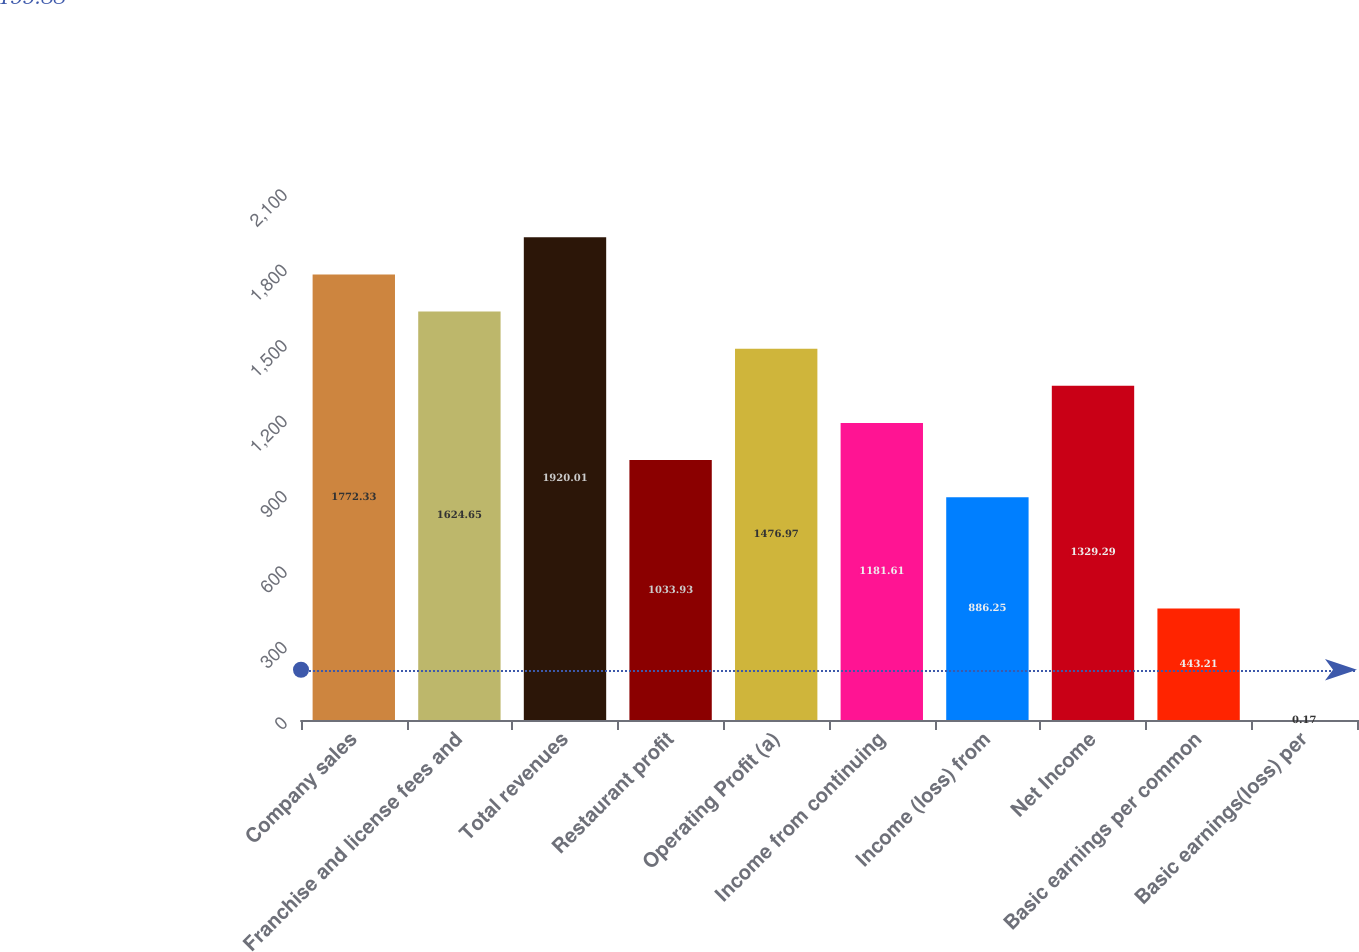<chart> <loc_0><loc_0><loc_500><loc_500><bar_chart><fcel>Company sales<fcel>Franchise and license fees and<fcel>Total revenues<fcel>Restaurant profit<fcel>Operating Profit (a)<fcel>Income from continuing<fcel>Income (loss) from<fcel>Net Income<fcel>Basic earnings per common<fcel>Basic earnings(loss) per<nl><fcel>1772.33<fcel>1624.65<fcel>1920.01<fcel>1033.93<fcel>1476.97<fcel>1181.61<fcel>886.25<fcel>1329.29<fcel>443.21<fcel>0.17<nl></chart> 